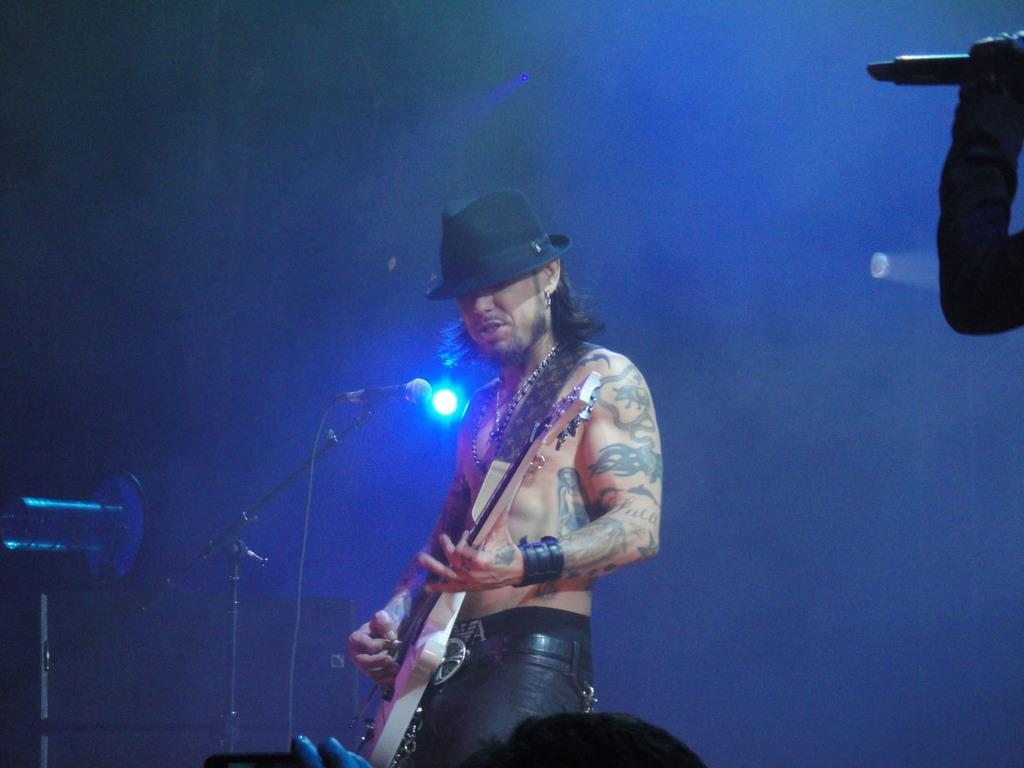What is the man in the image doing? The man in the image is playing a guitar. What can be seen in the background of the image? There is a microphone in the background. How many people are present in the image? There are two people in the image. What is the other person holding? The other person is holding a microphone. What type of leather is visible on the feet of the man in the image? There is no leather visible on the feet of the man in the image, as the facts provided do not mention anything about the man's footwear. 